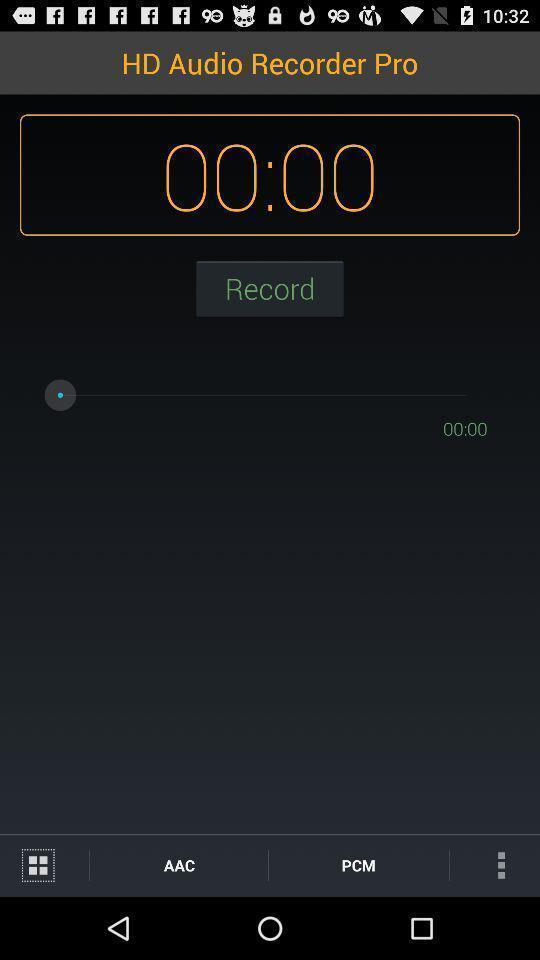Please provide a description for this image. Record button page in an audio recorder app. 